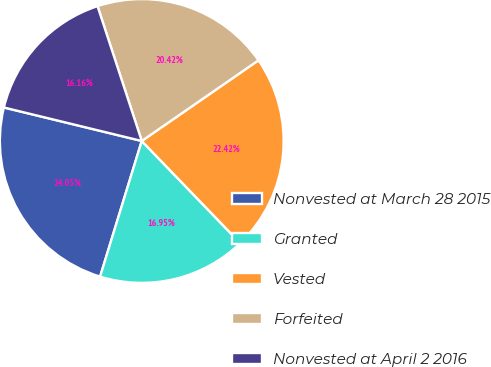Convert chart to OTSL. <chart><loc_0><loc_0><loc_500><loc_500><pie_chart><fcel>Nonvested at March 28 2015<fcel>Granted<fcel>Vested<fcel>Forfeited<fcel>Nonvested at April 2 2016<nl><fcel>24.05%<fcel>16.95%<fcel>22.42%<fcel>20.42%<fcel>16.16%<nl></chart> 